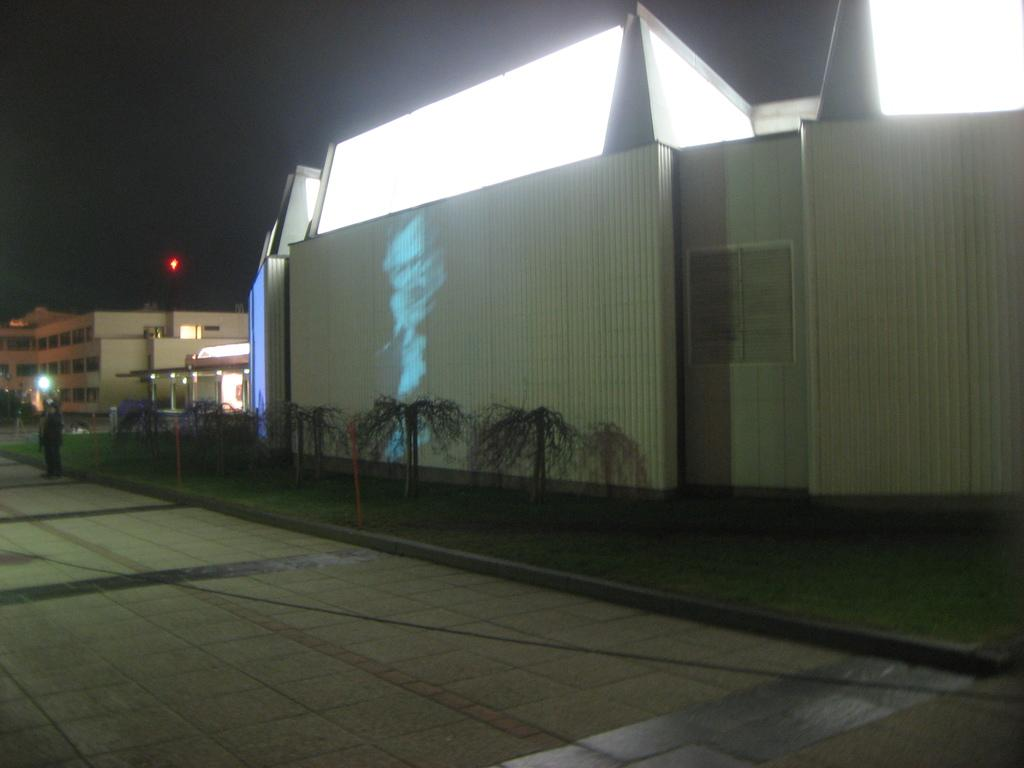What is located in the center of the image? There are buildings in the center of the image. What can be seen on the screen in the image? The facts do not specify what is on the screen, so we cannot answer that question definitively. What type of vegetation is present in the image? There are plants in the image. What is the man on the left side of the image doing? The facts do not specify what the man is doing, so we cannot answer that question definitively. What is visible at the top of the image? The sky is visible at the top of the image. What type of lighting is present in the image? There are lights visible in the image. How many cats are playing with bubbles in the image? There are no cats or bubbles present in the image. What type of change is the man making in the image? The facts do not specify any change being made by the man, so we cannot answer that question definitively. 